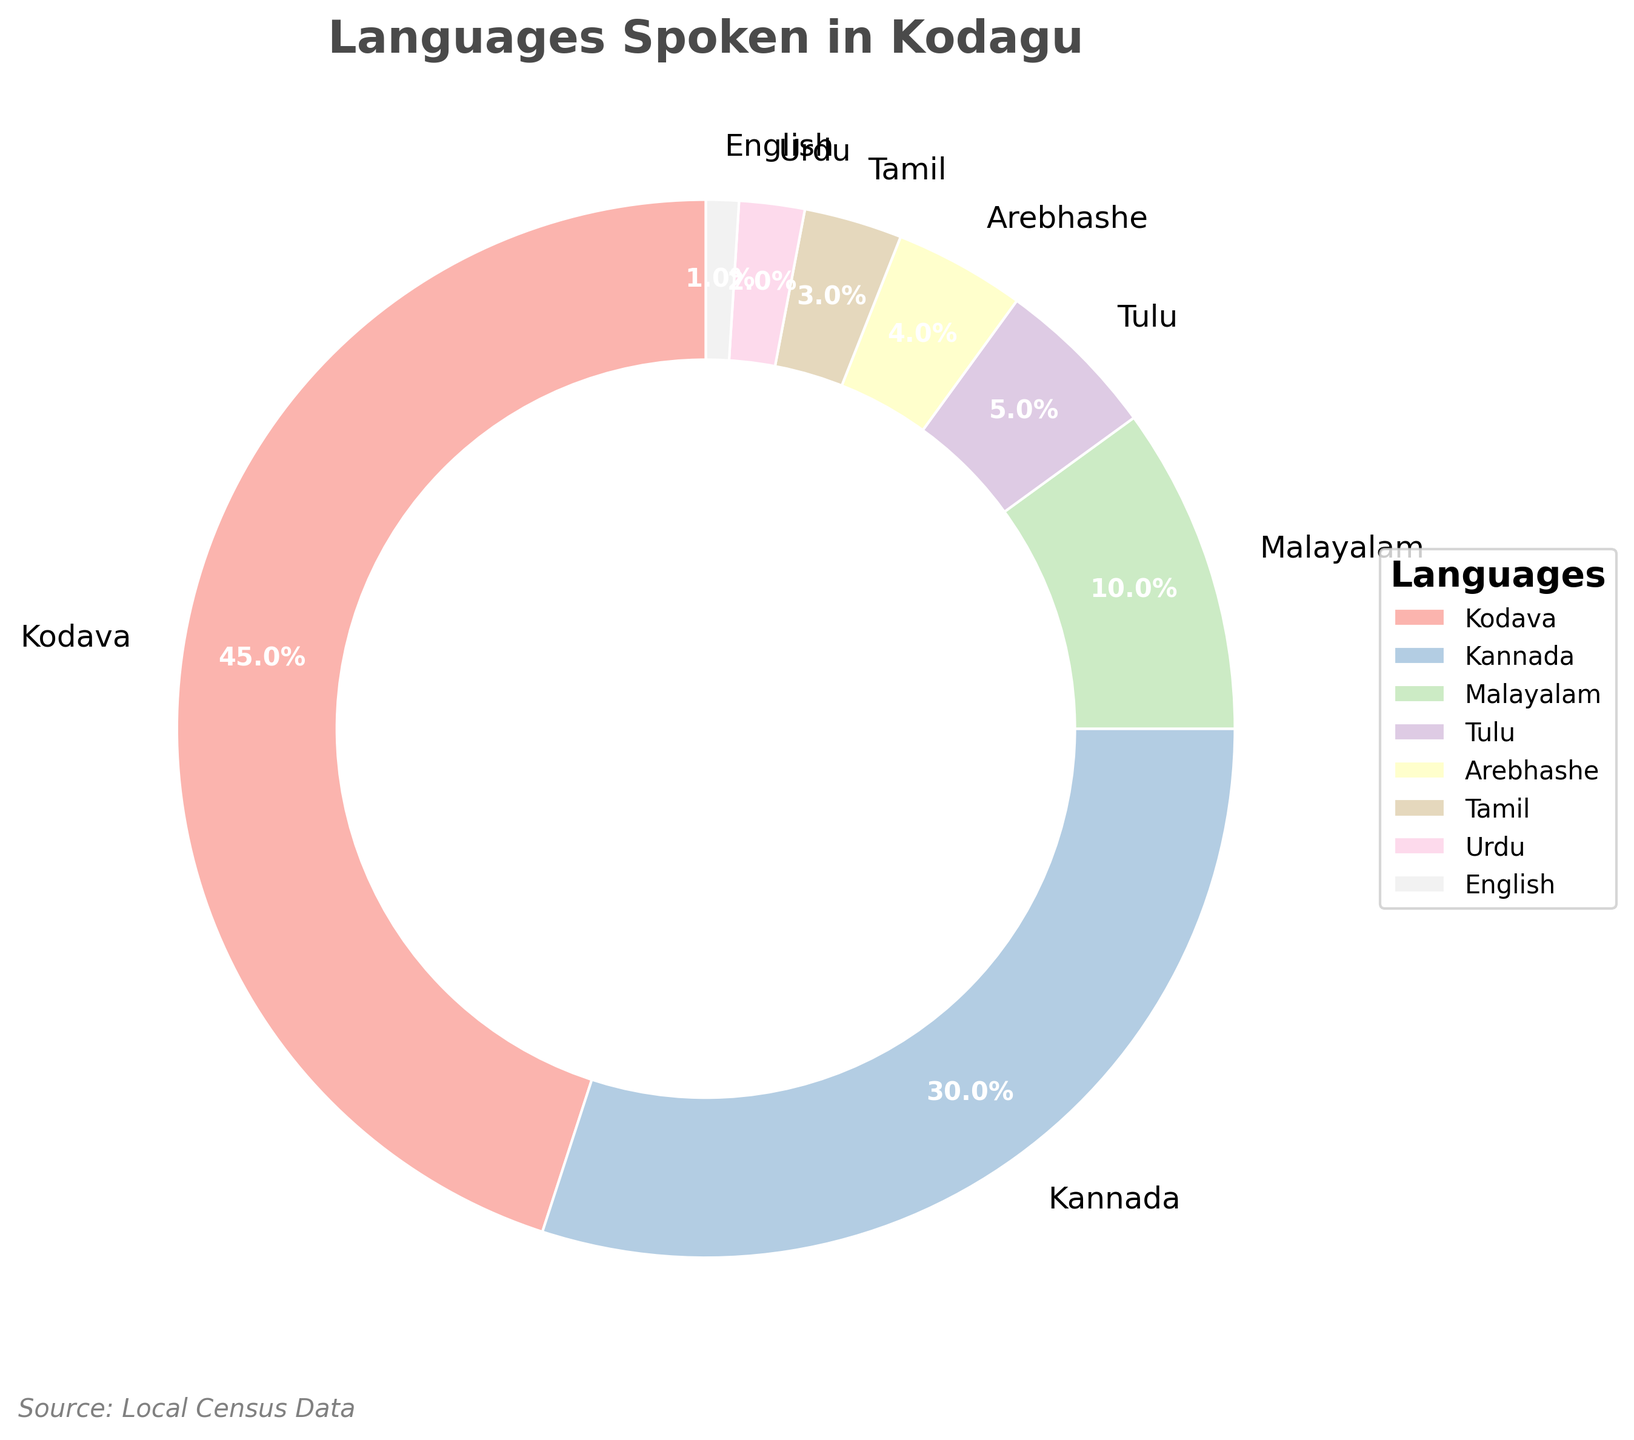What percentage of the Kodagu population speaks Kodava and Kannada combined? To find the combined percentage of the Kodagu population that speaks Kodava and Kannada, add the percentages for both languages from the figure. Kodava has 45% and Kannada has 30%. Thus, the combined percentage is 45% + 30% = 75%.
Answer: 75% Which language has the smallest percentage of speakers, and what is that percentage? To identify the language with the smallest percentage of speakers, find the language with the lowest percentage in the figure. According to the data, English has the smallest percentage of speakers at 1%.
Answer: English, 1% How much larger is the percentage of Kodava speakers compared to the percentage of Malayalam speakers? To find how much larger the percentage of Kodava speakers is compared to Malayalam speakers, subtract the percentage of Malayalam speakers from the percentage of Kodava speakers. Kodava has 45% while Malayalam has 10%, so the difference is 45% - 10% = 35%.
Answer: 35% Which two languages have the closest percentages of speakers, and what are those percentages? To find the two languages with the closest percentages of speakers, compare the differences between each pair of percentages. Kannada has 30%, Malayalam 10%, Tulu 5%, Arebhashe 4%, Tamil 3%, Urdu 2%, and English 1%. The closest percentages are those of Arebhashe (4%) and Tamil (3%), with a difference of 1%.
Answer: Arebhashe, Tamil; 4%, 3% What is the total percentage of the Kodagu population that speaks Tulu, Arebhashe, Tamil, Urdu, and English? Sum the percentages of Tulu (5%), Arebhashe (4%), Tamil (3%), Urdu (2%), and English (1%) to get the total. Adding these gives 5% + 4% + 3% + 2% + 1% = 15%.
Answer: 15% How does the percentage of Malayalam speakers compare to the combined percentage of speakers of Tamil and Urdu? The percentage of Malayalam speakers is 10%, while the combined percentage of Tamil (3%) and Urdu (2%) is 3% + 2% = 5%. Malayalam has a higher percentage of speakers by 5%.
Answer: 5% higher Which language sections are represented in lighter colors in the pie chart, and what are the respective percentages? The pie chart likely uses a color gradient; hence the lighter colors typically represent smaller percentages. The smallest percentages are those of Tulu (5%), Arebhashe (4%), Tamil (3%), Urdu (2%), and English (1%).
Answer: Tulu, Arebhashe, Tamil, Urdu, English; 5%, 4%, 3%, 2%, 1% What is the difference in the percentage of speakers between Kannada and the next most spoken language? Kannada has 30% speakers, and the next most spoken language is Malayalam with 10%. The difference between them is 30% - 10% = 20%.
Answer: 20% 